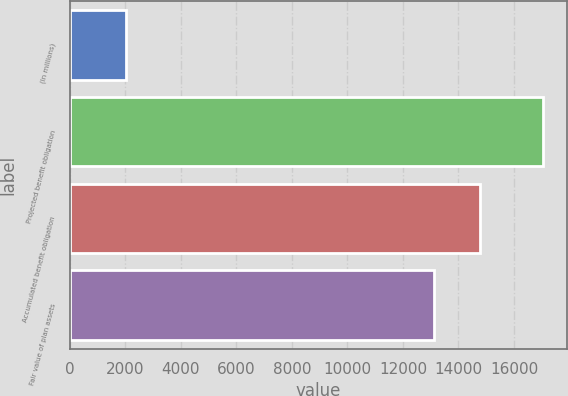<chart> <loc_0><loc_0><loc_500><loc_500><bar_chart><fcel>(In millions)<fcel>Projected benefit obligation<fcel>Accumulated benefit obligation<fcel>Fair value of plan assets<nl><fcel>2004<fcel>17051<fcel>14792<fcel>13132<nl></chart> 